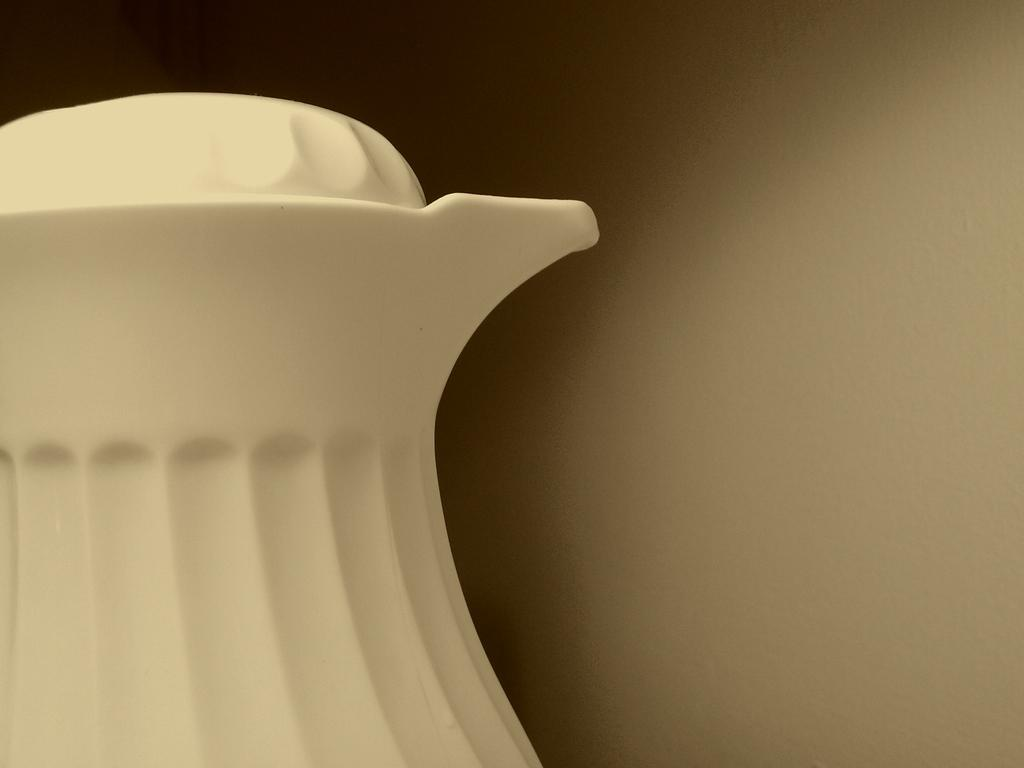What object is the main focus of the picture? There is a jug in the picture. What can be seen behind the jug in the image? The background of the image is plain. How many people are present in the crowd behind the jug in the image? There is no crowd or person present in the image; it only features a jug with a plain background. 